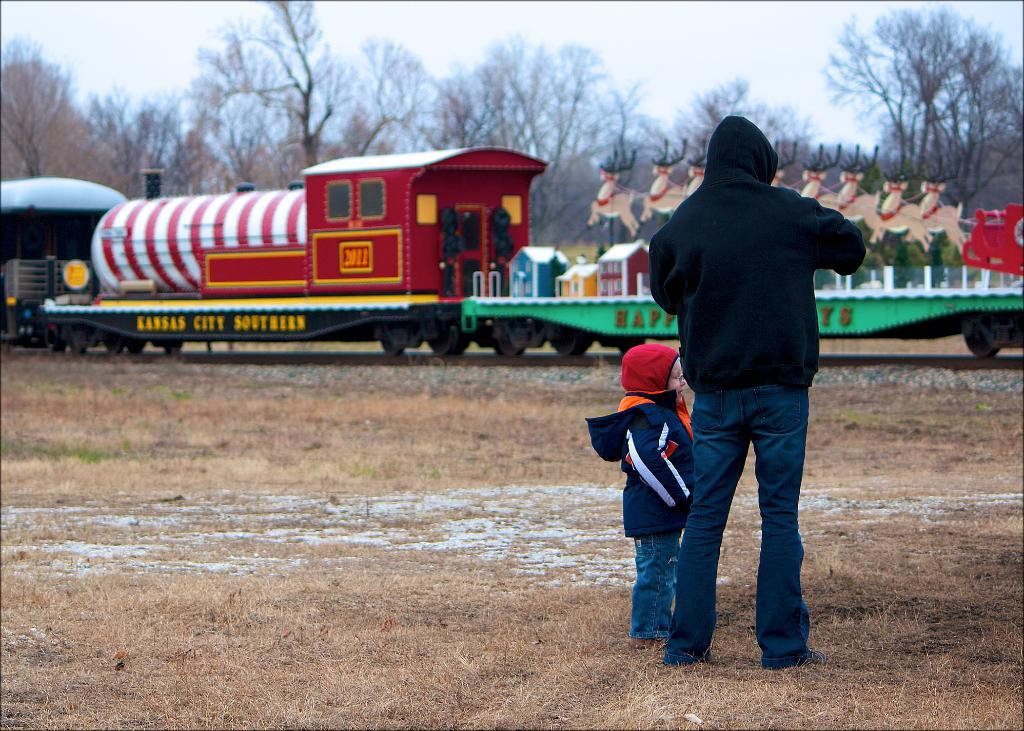Who is present in the image? There is a person and a kid in the image. What are the person and the kid doing in the image? Both the person and the kid are standing on the ground. What can be seen in the background of the image? There are trees and the sky visible in the background of the image. What is the main subject in the foreground of the image? There is a train in the image. What is on the train? There are objects on the train. What type of reaction can be seen in the image? There is no specific reaction visible in the image; it simply shows a person and a kid standing on the ground near a train. How many quarters are visible on the train in the image? There are no quarters visible on the train in the image. 